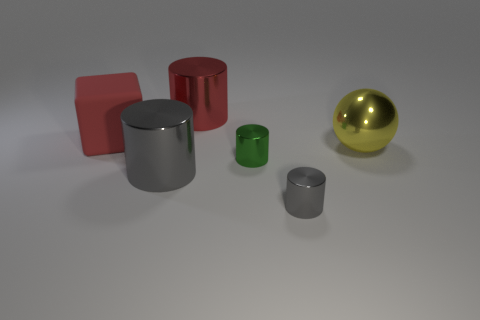Is the color of the large cylinder that is left of the big red shiny thing the same as the big matte block?
Your answer should be compact. No. The red metallic thing that is the same shape as the tiny gray metallic object is what size?
Your response must be concise. Large. Are there any other things that have the same size as the red metal object?
Your answer should be compact. Yes. What is the material of the big yellow thing to the right of the small shiny thing on the left side of the cylinder in front of the large gray shiny cylinder?
Make the answer very short. Metal. Are there more red blocks that are on the left side of the tiny gray cylinder than large shiny cylinders on the left side of the large gray metal cylinder?
Make the answer very short. Yes. Do the red cylinder and the yellow ball have the same size?
Your response must be concise. Yes. There is another large object that is the same shape as the big gray object; what is its color?
Give a very brief answer. Red. How many objects are the same color as the cube?
Your answer should be very brief. 1. Is the number of big gray metal cylinders that are on the left side of the rubber cube greater than the number of big yellow objects?
Your answer should be very brief. No. There is a metallic cylinder on the left side of the shiny cylinder that is behind the green shiny object; what color is it?
Ensure brevity in your answer.  Gray. 